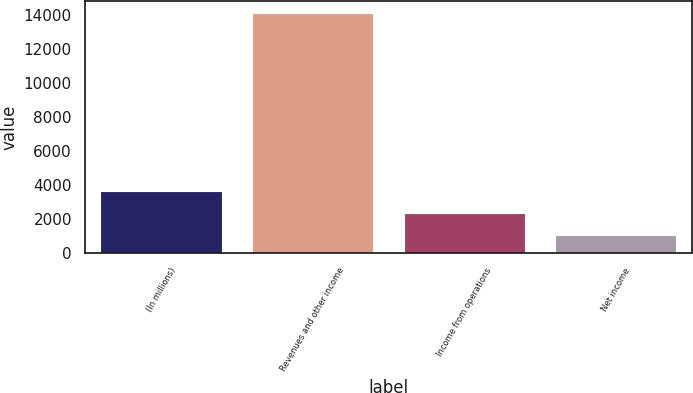<chart> <loc_0><loc_0><loc_500><loc_500><bar_chart><fcel>(In millions)<fcel>Revenues and other income<fcel>Income from operations<fcel>Net income<nl><fcel>3657<fcel>14133<fcel>2347.5<fcel>1038<nl></chart> 